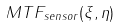Convert formula to latex. <formula><loc_0><loc_0><loc_500><loc_500>M T F _ { s e n s o r } ( \xi , \eta )</formula> 